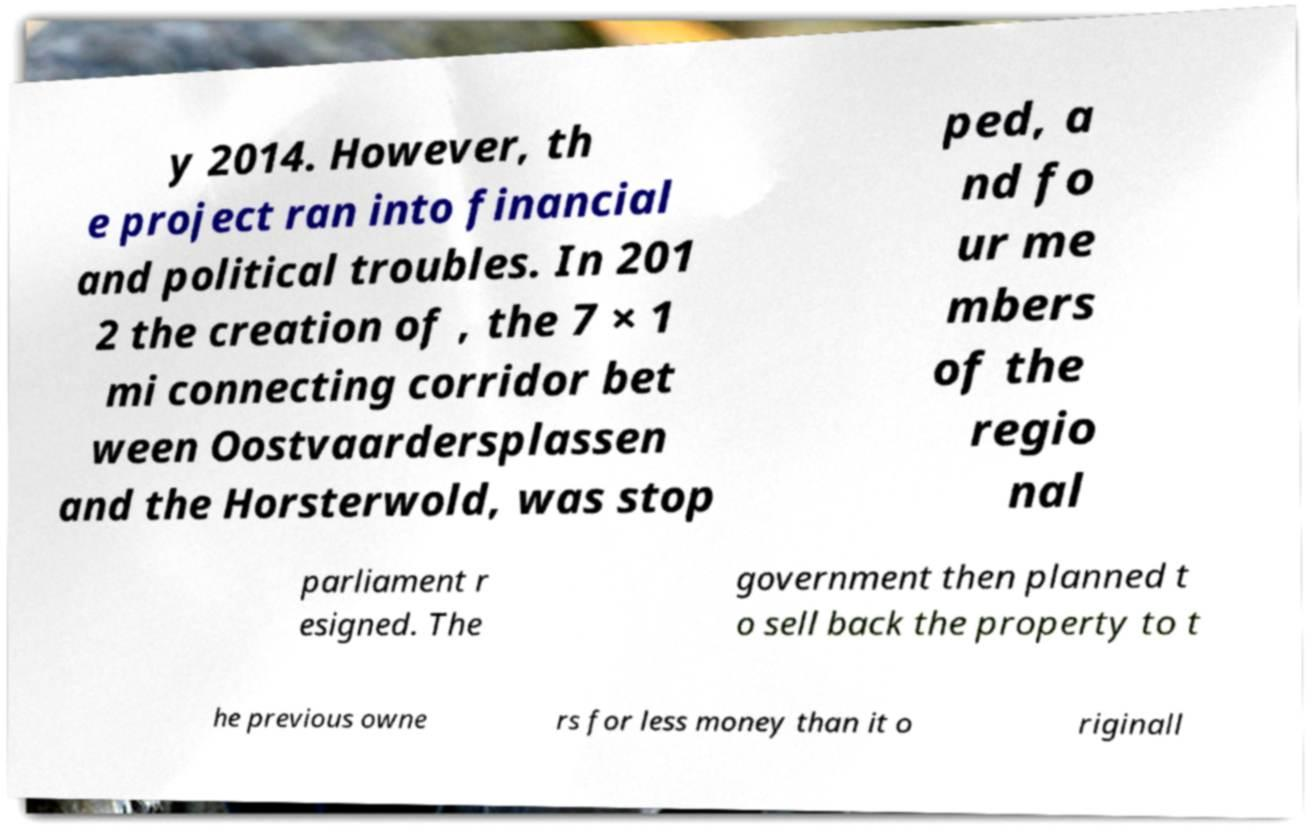Can you accurately transcribe the text from the provided image for me? y 2014. However, th e project ran into financial and political troubles. In 201 2 the creation of , the 7 × 1 mi connecting corridor bet ween Oostvaardersplassen and the Horsterwold, was stop ped, a nd fo ur me mbers of the regio nal parliament r esigned. The government then planned t o sell back the property to t he previous owne rs for less money than it o riginall 